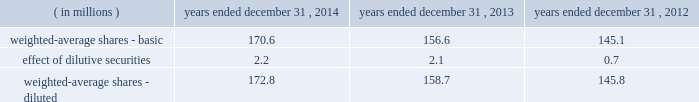Related employer payroll tax costs ) .
The contributions of these amounts are due by march 15 of the calendar year following the year in which the company realizes the benefits of the deductions .
This arrangement has been accounted for as contingent consideration .
Pre-2009 business combinations were accounted for under a former accounting standard which , among other aspects , precluded the recognition of certain contingent consideration as of the business combination date .
Instead , under the former accounting standard , contingent consideration is accounted for as additional purchase price ( goodwill ) at the time the contingency is resolved .
As of december 31 , 2013 , the company accrued $ 20.9 million related to this arrangement within other current liabilities , as the company realized the tax benefit of the compensation deductions during the 2013 tax year .
The company made the related cash contribution during the first quarter of 2014 .
11 .
Earnings per share the numerator for both basic and diluted earnings per share is net income .
The denominator for basic earnings per share is the weighted-average number of common shares outstanding during the period .
The 2013 denominator was impacted by the common shares issued during both the ipo and the underwriters' exercise in full of the overallotment option granted to them in connection with the ipo .
Because such common shares were issued on july 2 , 2013 and july 31 , 2013 , respectively , they are only partially reflected in the 2013 denominator .
Such shares are fully reflected in the 2014 denominator .
See note 9 for additional discussion of the ipo .
The dilutive effect of outstanding restricted stock , restricted stock units , stock options , coworker stock purchase plan units and mpk plan units is reflected in the denominator for diluted earnings per share using the treasury stock method .
The following is a reconciliation of basic shares to diluted shares: .
There was an insignificant amount of potential common shares excluded from diluted earnings per share for the years ended december 31 , 2014 , 2013 and 2012 , as their inclusion would have had an anti-dilutive effect .
12 .
Deferred compensation plan on march 10 , 2010 , in connection with the company 2019s purchase of $ 28.5 million principal amount of its outstanding senior subordinated debt , the company established the restricted debt unit plan ( the 201crdu plan 201d ) , an unfunded nonqualified deferred compensation plan .
The total number of rdus that could be granted under the rdu plan was 28500 .
As of december 31 , 2014 , 28500 rdus were outstanding .
Rdus vested daily on a pro rata basis over the three-year period from january 1 , 2012 ( or , if later , the date of hire or the date of a subsequent rdu grant ) through december 31 , 2014 .
All outstanding rdus were vested as of december 31 , 2014 .
Participants have no rights to the underlying debt .
The total amount of compensation available to be paid under the rdu plan was initially to be based on two components , a principal component and an interest component .
The principal component credits the rdu plan with a notional amount equal to the $ 28.5 million face value of the senior subordinated notes ( the "debt pool" ) , together with certain redemption premium equivalents as noted below .
The interest component credited the rdu plan with amounts equal to the interest that would have been earned on the debt pool from march 10 , 2010 through maturity on october 12 , 2017 , except as discussed below .
Interest amounts for 2010 and 2011 were deferred until 2012 , and thereafter , interest amounts were paid to participants semi-annually on the interest payment due dates .
The company used a portion of the ipo proceeds together with incremental borrowings to redeem $ 324.0 million of the total senior subordinated notes outstanding on august 1 , 2013 .
In connection with the ipo and the partial redemption of the senior subordinated notes , the company amended the rdu plan to increase the retentive value of the plan .
In accordance with the original terms of the rdu plan , the principal component of the rdus converted to a cash-denominated pool upon the redemption of the senior subordinated notes .
In addition , the company added $ 0.1 table of contents cdw corporation and subsidiaries notes to consolidated financial statements .
What was the average , in millions , of weighted-average diluted shares from 2012-2014? 
Computations: (((172.8 + 158.7) + 145.8) / 3)
Answer: 159.1. Related employer payroll tax costs ) .
The contributions of these amounts are due by march 15 of the calendar year following the year in which the company realizes the benefits of the deductions .
This arrangement has been accounted for as contingent consideration .
Pre-2009 business combinations were accounted for under a former accounting standard which , among other aspects , precluded the recognition of certain contingent consideration as of the business combination date .
Instead , under the former accounting standard , contingent consideration is accounted for as additional purchase price ( goodwill ) at the time the contingency is resolved .
As of december 31 , 2013 , the company accrued $ 20.9 million related to this arrangement within other current liabilities , as the company realized the tax benefit of the compensation deductions during the 2013 tax year .
The company made the related cash contribution during the first quarter of 2014 .
11 .
Earnings per share the numerator for both basic and diluted earnings per share is net income .
The denominator for basic earnings per share is the weighted-average number of common shares outstanding during the period .
The 2013 denominator was impacted by the common shares issued during both the ipo and the underwriters' exercise in full of the overallotment option granted to them in connection with the ipo .
Because such common shares were issued on july 2 , 2013 and july 31 , 2013 , respectively , they are only partially reflected in the 2013 denominator .
Such shares are fully reflected in the 2014 denominator .
See note 9 for additional discussion of the ipo .
The dilutive effect of outstanding restricted stock , restricted stock units , stock options , coworker stock purchase plan units and mpk plan units is reflected in the denominator for diluted earnings per share using the treasury stock method .
The following is a reconciliation of basic shares to diluted shares: .
There was an insignificant amount of potential common shares excluded from diluted earnings per share for the years ended december 31 , 2014 , 2013 and 2012 , as their inclusion would have had an anti-dilutive effect .
12 .
Deferred compensation plan on march 10 , 2010 , in connection with the company 2019s purchase of $ 28.5 million principal amount of its outstanding senior subordinated debt , the company established the restricted debt unit plan ( the 201crdu plan 201d ) , an unfunded nonqualified deferred compensation plan .
The total number of rdus that could be granted under the rdu plan was 28500 .
As of december 31 , 2014 , 28500 rdus were outstanding .
Rdus vested daily on a pro rata basis over the three-year period from january 1 , 2012 ( or , if later , the date of hire or the date of a subsequent rdu grant ) through december 31 , 2014 .
All outstanding rdus were vested as of december 31 , 2014 .
Participants have no rights to the underlying debt .
The total amount of compensation available to be paid under the rdu plan was initially to be based on two components , a principal component and an interest component .
The principal component credits the rdu plan with a notional amount equal to the $ 28.5 million face value of the senior subordinated notes ( the "debt pool" ) , together with certain redemption premium equivalents as noted below .
The interest component credited the rdu plan with amounts equal to the interest that would have been earned on the debt pool from march 10 , 2010 through maturity on october 12 , 2017 , except as discussed below .
Interest amounts for 2010 and 2011 were deferred until 2012 , and thereafter , interest amounts were paid to participants semi-annually on the interest payment due dates .
The company used a portion of the ipo proceeds together with incremental borrowings to redeem $ 324.0 million of the total senior subordinated notes outstanding on august 1 , 2013 .
In connection with the ipo and the partial redemption of the senior subordinated notes , the company amended the rdu plan to increase the retentive value of the plan .
In accordance with the original terms of the rdu plan , the principal component of the rdus converted to a cash-denominated pool upon the redemption of the senior subordinated notes .
In addition , the company added $ 0.1 table of contents cdw corporation and subsidiaries notes to consolidated financial statements .
What was the average , in millions , of weighted-average diluted shares from 2012-2014? 
Computations: (((172.8 + 158.7) + 145.8) / 3)
Answer: 159.1. Related employer payroll tax costs ) .
The contributions of these amounts are due by march 15 of the calendar year following the year in which the company realizes the benefits of the deductions .
This arrangement has been accounted for as contingent consideration .
Pre-2009 business combinations were accounted for under a former accounting standard which , among other aspects , precluded the recognition of certain contingent consideration as of the business combination date .
Instead , under the former accounting standard , contingent consideration is accounted for as additional purchase price ( goodwill ) at the time the contingency is resolved .
As of december 31 , 2013 , the company accrued $ 20.9 million related to this arrangement within other current liabilities , as the company realized the tax benefit of the compensation deductions during the 2013 tax year .
The company made the related cash contribution during the first quarter of 2014 .
11 .
Earnings per share the numerator for both basic and diluted earnings per share is net income .
The denominator for basic earnings per share is the weighted-average number of common shares outstanding during the period .
The 2013 denominator was impacted by the common shares issued during both the ipo and the underwriters' exercise in full of the overallotment option granted to them in connection with the ipo .
Because such common shares were issued on july 2 , 2013 and july 31 , 2013 , respectively , they are only partially reflected in the 2013 denominator .
Such shares are fully reflected in the 2014 denominator .
See note 9 for additional discussion of the ipo .
The dilutive effect of outstanding restricted stock , restricted stock units , stock options , coworker stock purchase plan units and mpk plan units is reflected in the denominator for diluted earnings per share using the treasury stock method .
The following is a reconciliation of basic shares to diluted shares: .
There was an insignificant amount of potential common shares excluded from diluted earnings per share for the years ended december 31 , 2014 , 2013 and 2012 , as their inclusion would have had an anti-dilutive effect .
12 .
Deferred compensation plan on march 10 , 2010 , in connection with the company 2019s purchase of $ 28.5 million principal amount of its outstanding senior subordinated debt , the company established the restricted debt unit plan ( the 201crdu plan 201d ) , an unfunded nonqualified deferred compensation plan .
The total number of rdus that could be granted under the rdu plan was 28500 .
As of december 31 , 2014 , 28500 rdus were outstanding .
Rdus vested daily on a pro rata basis over the three-year period from january 1 , 2012 ( or , if later , the date of hire or the date of a subsequent rdu grant ) through december 31 , 2014 .
All outstanding rdus were vested as of december 31 , 2014 .
Participants have no rights to the underlying debt .
The total amount of compensation available to be paid under the rdu plan was initially to be based on two components , a principal component and an interest component .
The principal component credits the rdu plan with a notional amount equal to the $ 28.5 million face value of the senior subordinated notes ( the "debt pool" ) , together with certain redemption premium equivalents as noted below .
The interest component credited the rdu plan with amounts equal to the interest that would have been earned on the debt pool from march 10 , 2010 through maturity on october 12 , 2017 , except as discussed below .
Interest amounts for 2010 and 2011 were deferred until 2012 , and thereafter , interest amounts were paid to participants semi-annually on the interest payment due dates .
The company used a portion of the ipo proceeds together with incremental borrowings to redeem $ 324.0 million of the total senior subordinated notes outstanding on august 1 , 2013 .
In connection with the ipo and the partial redemption of the senior subordinated notes , the company amended the rdu plan to increase the retentive value of the plan .
In accordance with the original terms of the rdu plan , the principal component of the rdus converted to a cash-denominated pool upon the redemption of the senior subordinated notes .
In addition , the company added $ 0.1 table of contents cdw corporation and subsidiaries notes to consolidated financial statements .
For rdus vested daily on a pro rata basis over the three-year period from january 1 , 2012 , what was the average rdus vesting each year through december 31 , 2014?\\n\\n[13] : as of december 31 , 2014 , 28500 rdus were outstanding .? 
Computations: (28500 / 3)
Answer: 9500.0. 